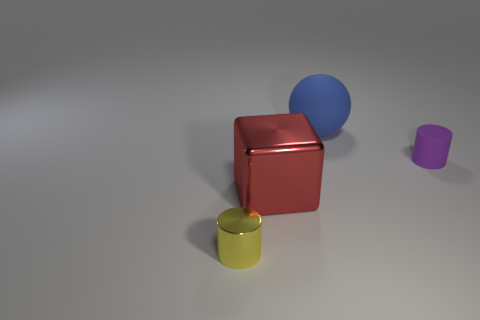There is another thing that is the same shape as the small yellow thing; what material is it?
Give a very brief answer. Rubber. Are there more big blue things that are on the left side of the yellow metallic cylinder than big blue objects that are in front of the small purple cylinder?
Your answer should be compact. No. What is the material of the small yellow cylinder?
Provide a succinct answer. Metal. Are there any blue things of the same size as the metallic cylinder?
Your response must be concise. No. What material is the cube that is the same size as the matte ball?
Ensure brevity in your answer.  Metal. How many rubber objects are there?
Keep it short and to the point. 2. There is a metallic object behind the tiny yellow metallic object; what size is it?
Provide a short and direct response. Large. Are there the same number of red shiny cubes in front of the block and purple cylinders?
Your answer should be very brief. No. Are there any big red metal objects that have the same shape as the small purple object?
Your response must be concise. No. What is the shape of the thing that is both to the left of the large blue object and to the right of the small yellow thing?
Your answer should be compact. Cube. 